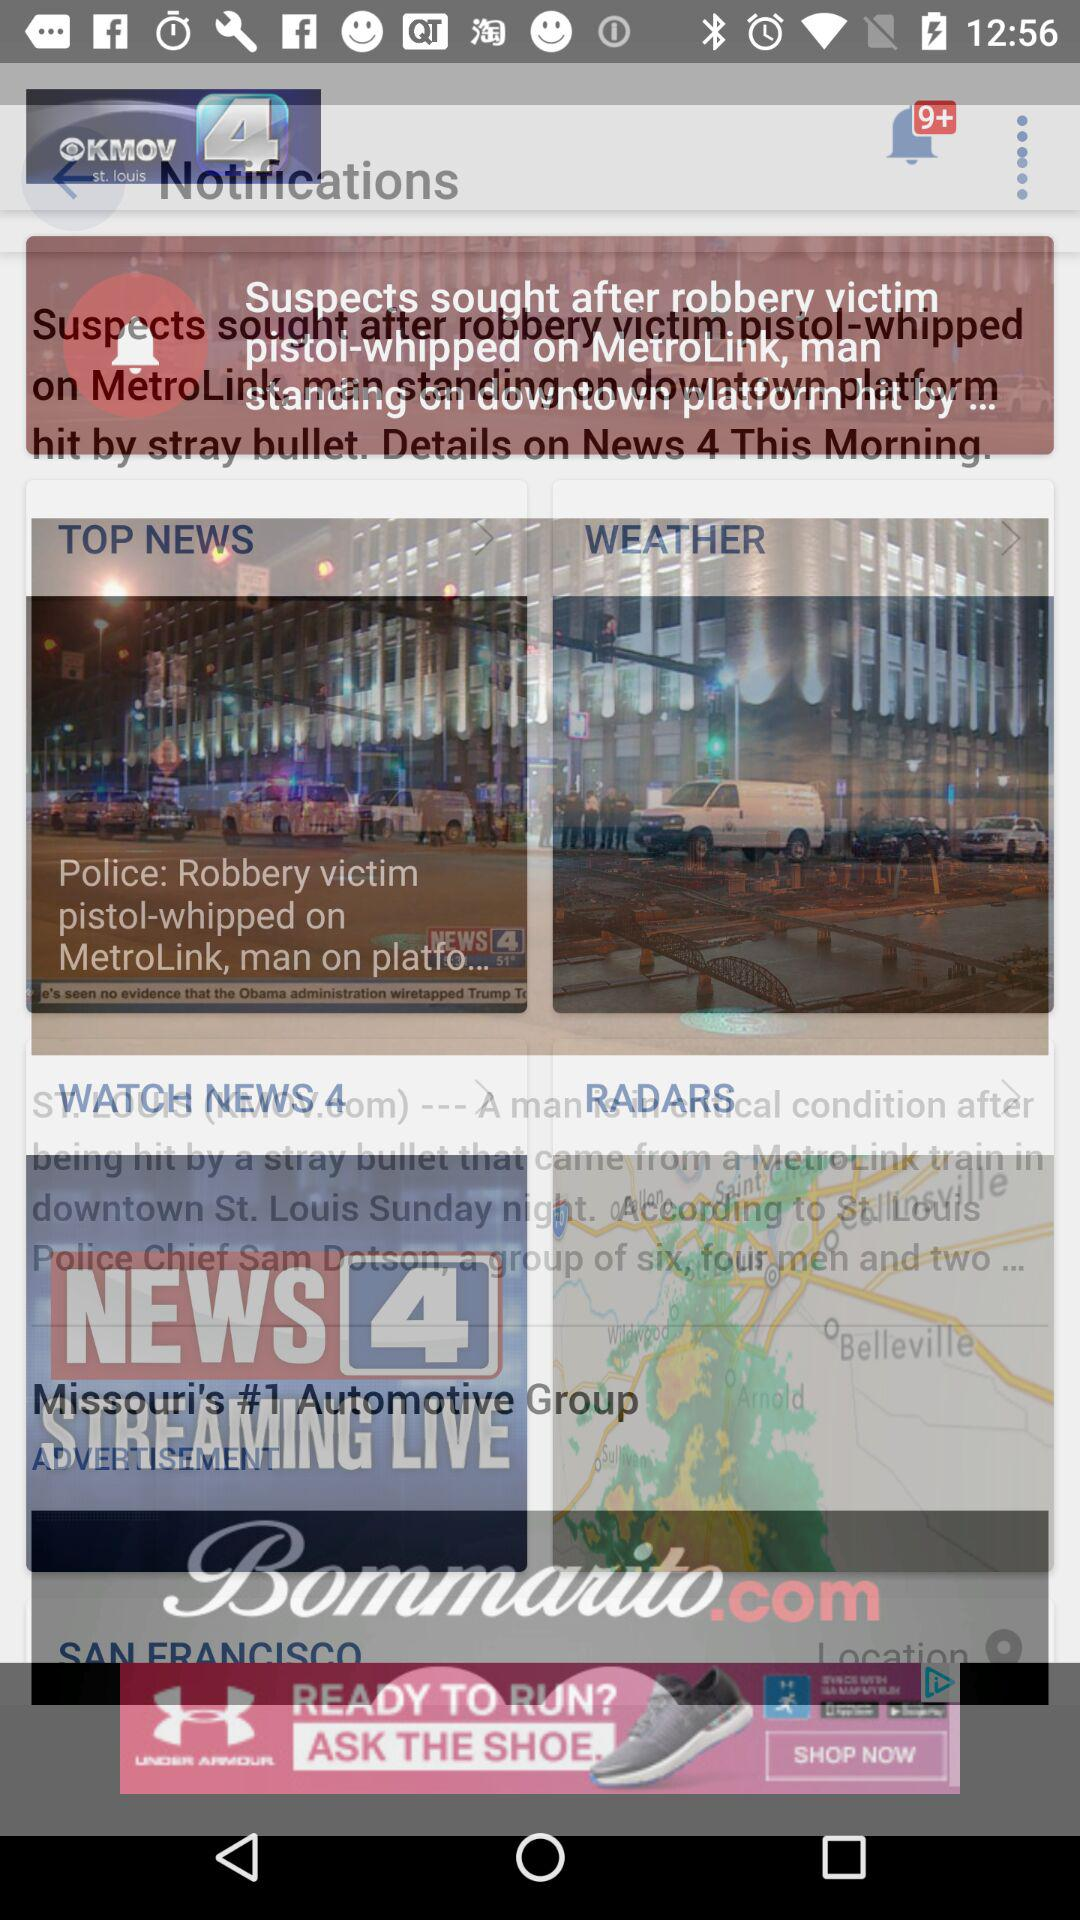What is the name of the television station? The name of the television station is "KMOV". 